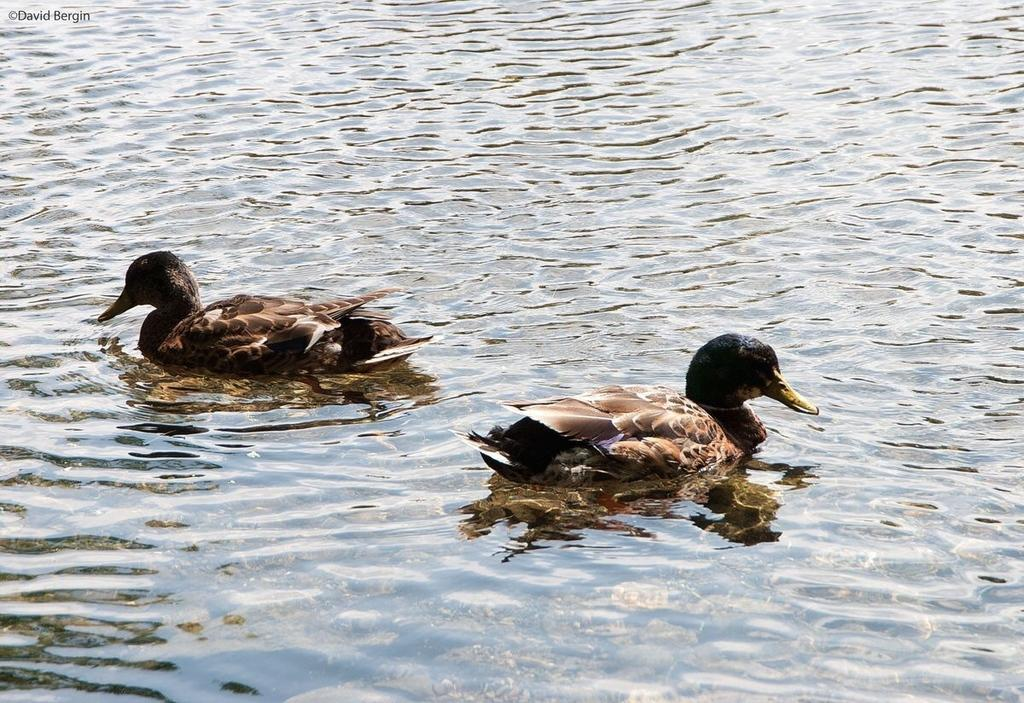What animals can be seen in the image? There are birds on the surface of the water in the image. Can you describe any text present in the image? Yes, there is text visible in the top left corner of the image. What type of toys can be seen floating in the water with the birds? There are no toys visible in the image; it only features birds on the water's surface. 